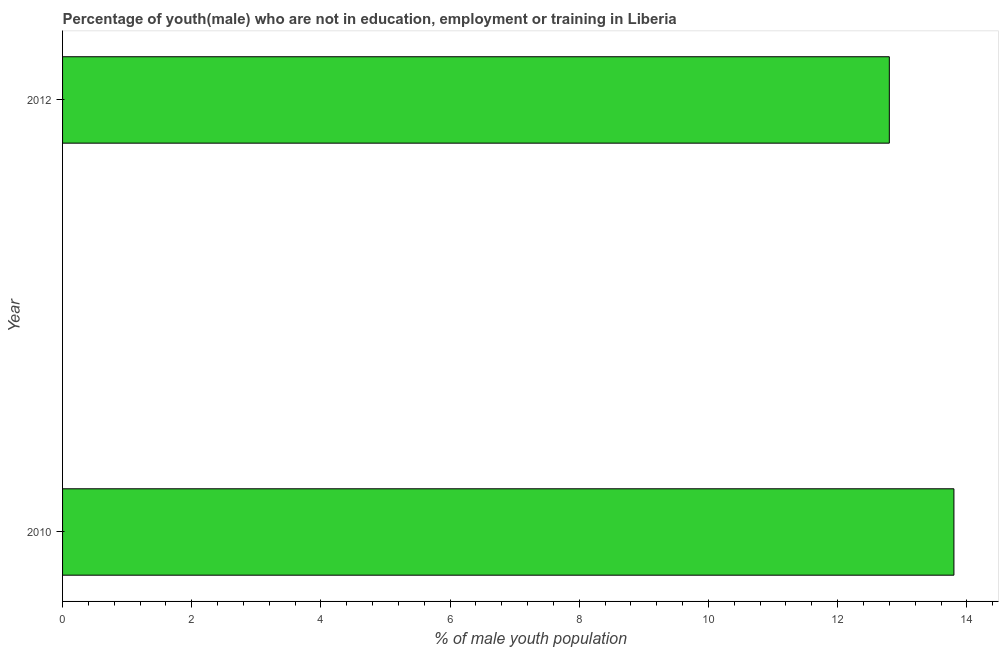Does the graph contain any zero values?
Your answer should be compact. No. Does the graph contain grids?
Your answer should be very brief. No. What is the title of the graph?
Ensure brevity in your answer.  Percentage of youth(male) who are not in education, employment or training in Liberia. What is the label or title of the X-axis?
Offer a very short reply. % of male youth population. What is the unemployed male youth population in 2012?
Make the answer very short. 12.8. Across all years, what is the maximum unemployed male youth population?
Ensure brevity in your answer.  13.8. Across all years, what is the minimum unemployed male youth population?
Make the answer very short. 12.8. What is the sum of the unemployed male youth population?
Provide a succinct answer. 26.6. What is the difference between the unemployed male youth population in 2010 and 2012?
Your answer should be very brief. 1. What is the average unemployed male youth population per year?
Provide a succinct answer. 13.3. What is the median unemployed male youth population?
Provide a succinct answer. 13.3. Do a majority of the years between 2010 and 2012 (inclusive) have unemployed male youth population greater than 6.8 %?
Your answer should be compact. Yes. What is the ratio of the unemployed male youth population in 2010 to that in 2012?
Your answer should be compact. 1.08. Is the unemployed male youth population in 2010 less than that in 2012?
Offer a terse response. No. In how many years, is the unemployed male youth population greater than the average unemployed male youth population taken over all years?
Make the answer very short. 1. How many bars are there?
Your response must be concise. 2. How many years are there in the graph?
Give a very brief answer. 2. What is the % of male youth population in 2010?
Offer a very short reply. 13.8. What is the % of male youth population in 2012?
Your response must be concise. 12.8. What is the ratio of the % of male youth population in 2010 to that in 2012?
Provide a short and direct response. 1.08. 